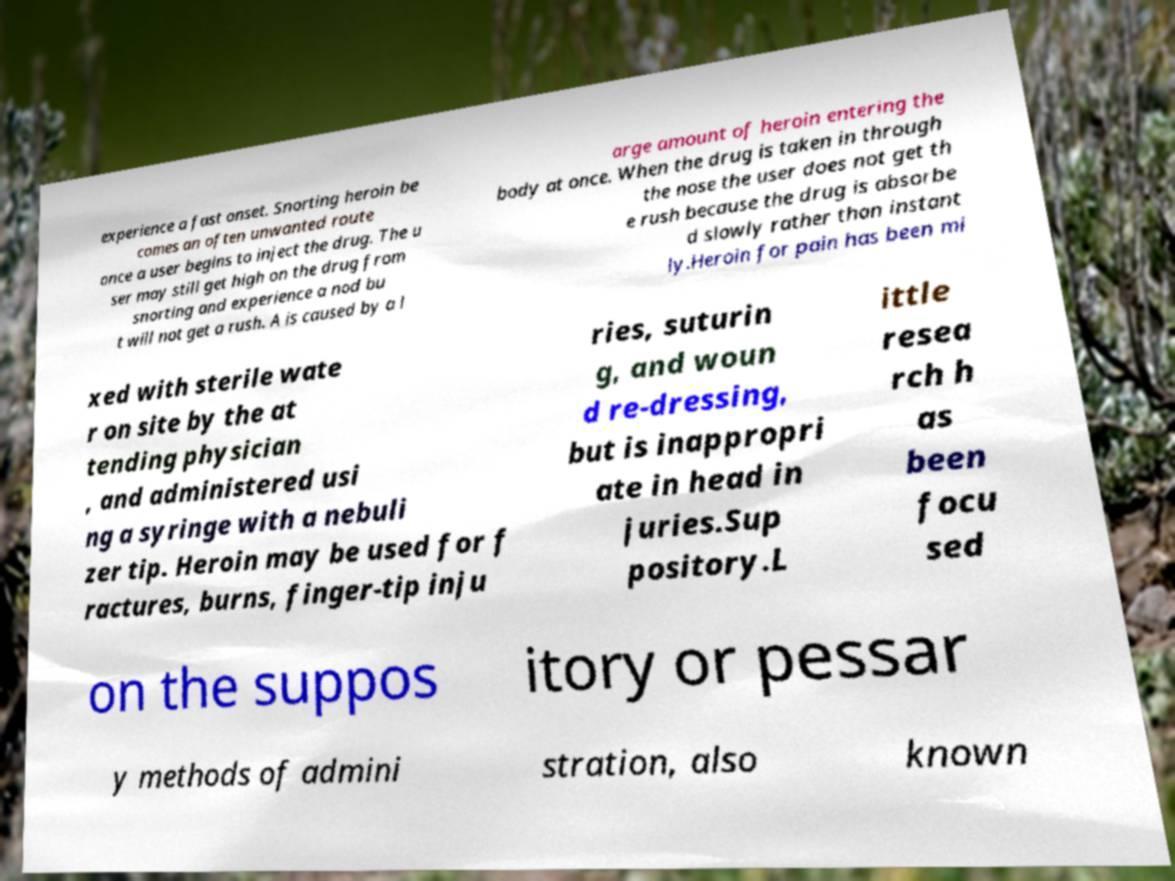I need the written content from this picture converted into text. Can you do that? experience a fast onset. Snorting heroin be comes an often unwanted route once a user begins to inject the drug. The u ser may still get high on the drug from snorting and experience a nod bu t will not get a rush. A is caused by a l arge amount of heroin entering the body at once. When the drug is taken in through the nose the user does not get th e rush because the drug is absorbe d slowly rather than instant ly.Heroin for pain has been mi xed with sterile wate r on site by the at tending physician , and administered usi ng a syringe with a nebuli zer tip. Heroin may be used for f ractures, burns, finger-tip inju ries, suturin g, and woun d re-dressing, but is inappropri ate in head in juries.Sup pository.L ittle resea rch h as been focu sed on the suppos itory or pessar y methods of admini stration, also known 